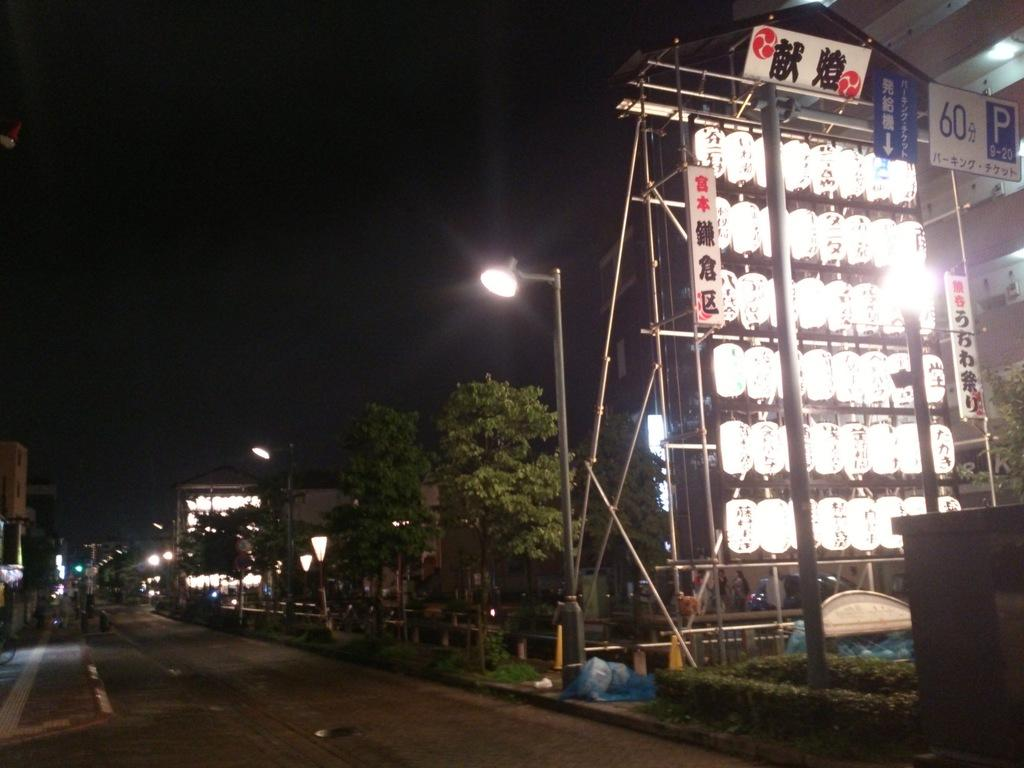<image>
Describe the image concisely. A well lit sign that notes the P section 9-20 